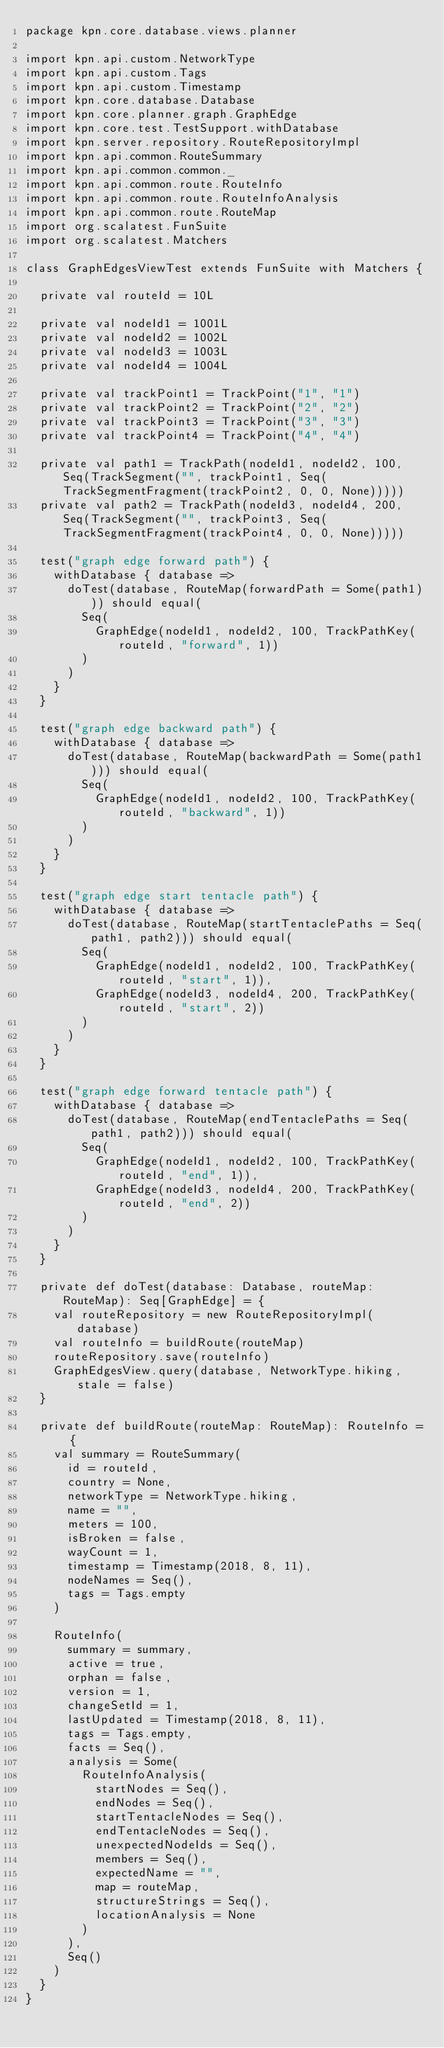Convert code to text. <code><loc_0><loc_0><loc_500><loc_500><_Scala_>package kpn.core.database.views.planner

import kpn.api.custom.NetworkType
import kpn.api.custom.Tags
import kpn.api.custom.Timestamp
import kpn.core.database.Database
import kpn.core.planner.graph.GraphEdge
import kpn.core.test.TestSupport.withDatabase
import kpn.server.repository.RouteRepositoryImpl
import kpn.api.common.RouteSummary
import kpn.api.common.common._
import kpn.api.common.route.RouteInfo
import kpn.api.common.route.RouteInfoAnalysis
import kpn.api.common.route.RouteMap
import org.scalatest.FunSuite
import org.scalatest.Matchers

class GraphEdgesViewTest extends FunSuite with Matchers {

  private val routeId = 10L

  private val nodeId1 = 1001L
  private val nodeId2 = 1002L
  private val nodeId3 = 1003L
  private val nodeId4 = 1004L

  private val trackPoint1 = TrackPoint("1", "1")
  private val trackPoint2 = TrackPoint("2", "2")
  private val trackPoint3 = TrackPoint("3", "3")
  private val trackPoint4 = TrackPoint("4", "4")

  private val path1 = TrackPath(nodeId1, nodeId2, 100, Seq(TrackSegment("", trackPoint1, Seq(TrackSegmentFragment(trackPoint2, 0, 0, None)))))
  private val path2 = TrackPath(nodeId3, nodeId4, 200, Seq(TrackSegment("", trackPoint3, Seq(TrackSegmentFragment(trackPoint4, 0, 0, None)))))

  test("graph edge forward path") {
    withDatabase { database =>
      doTest(database, RouteMap(forwardPath = Some(path1))) should equal(
        Seq(
          GraphEdge(nodeId1, nodeId2, 100, TrackPathKey(routeId, "forward", 1))
        )
      )
    }
  }

  test("graph edge backward path") {
    withDatabase { database =>
      doTest(database, RouteMap(backwardPath = Some(path1))) should equal(
        Seq(
          GraphEdge(nodeId1, nodeId2, 100, TrackPathKey(routeId, "backward", 1))
        )
      )
    }
  }

  test("graph edge start tentacle path") {
    withDatabase { database =>
      doTest(database, RouteMap(startTentaclePaths = Seq(path1, path2))) should equal(
        Seq(
          GraphEdge(nodeId1, nodeId2, 100, TrackPathKey(routeId, "start", 1)),
          GraphEdge(nodeId3, nodeId4, 200, TrackPathKey(routeId, "start", 2))
        )
      )
    }
  }

  test("graph edge forward tentacle path") {
    withDatabase { database =>
      doTest(database, RouteMap(endTentaclePaths = Seq(path1, path2))) should equal(
        Seq(
          GraphEdge(nodeId1, nodeId2, 100, TrackPathKey(routeId, "end", 1)),
          GraphEdge(nodeId3, nodeId4, 200, TrackPathKey(routeId, "end", 2))
        )
      )
    }
  }

  private def doTest(database: Database, routeMap: RouteMap): Seq[GraphEdge] = {
    val routeRepository = new RouteRepositoryImpl(database)
    val routeInfo = buildRoute(routeMap)
    routeRepository.save(routeInfo)
    GraphEdgesView.query(database, NetworkType.hiking, stale = false)
  }

  private def buildRoute(routeMap: RouteMap): RouteInfo = {
    val summary = RouteSummary(
      id = routeId,
      country = None,
      networkType = NetworkType.hiking,
      name = "",
      meters = 100,
      isBroken = false,
      wayCount = 1,
      timestamp = Timestamp(2018, 8, 11),
      nodeNames = Seq(),
      tags = Tags.empty
    )

    RouteInfo(
      summary = summary,
      active = true,
      orphan = false,
      version = 1,
      changeSetId = 1,
      lastUpdated = Timestamp(2018, 8, 11),
      tags = Tags.empty,
      facts = Seq(),
      analysis = Some(
        RouteInfoAnalysis(
          startNodes = Seq(),
          endNodes = Seq(),
          startTentacleNodes = Seq(),
          endTentacleNodes = Seq(),
          unexpectedNodeIds = Seq(),
          members = Seq(),
          expectedName = "",
          map = routeMap,
          structureStrings = Seq(),
          locationAnalysis = None
        )
      ),
      Seq()
    )
  }
}
</code> 